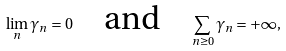<formula> <loc_0><loc_0><loc_500><loc_500>\lim _ { n } \gamma _ { n } = 0 \quad \text {and} \quad \sum _ { n \geq 0 } \gamma _ { n } = + \infty ,</formula> 